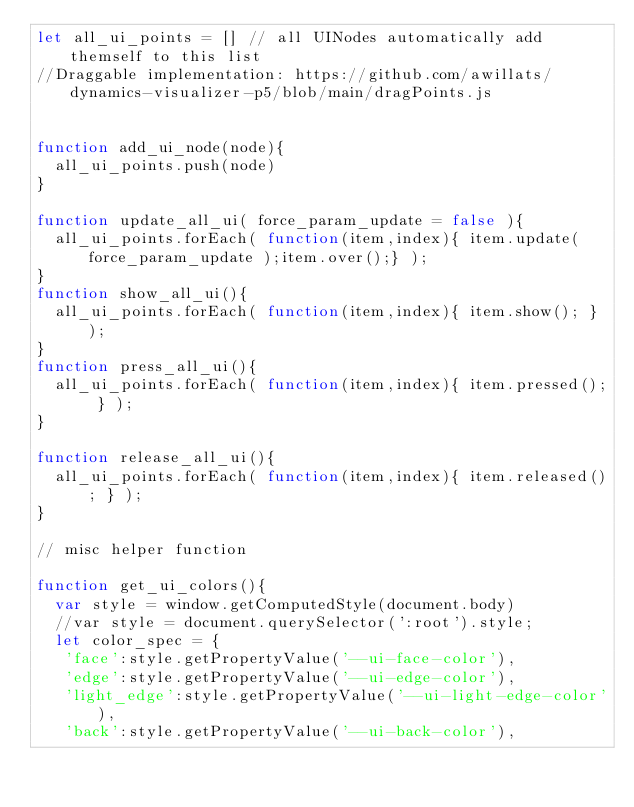<code> <loc_0><loc_0><loc_500><loc_500><_JavaScript_>let all_ui_points = [] // all UINodes automatically add themself to this list
//Draggable implementation: https://github.com/awillats/dynamics-visualizer-p5/blob/main/dragPoints.js


function add_ui_node(node){
  all_ui_points.push(node)
}

function update_all_ui( force_param_update = false ){
  all_ui_points.forEach( function(item,index){ item.update( force_param_update );item.over();} ); 
}
function show_all_ui(){
  all_ui_points.forEach( function(item,index){ item.show(); } ); 
}
function press_all_ui(){
  all_ui_points.forEach( function(item,index){ item.pressed(); } ); 
}

function release_all_ui(){
  all_ui_points.forEach( function(item,index){ item.released(); } ); 
}

// misc helper function 

function get_ui_colors(){
  var style = window.getComputedStyle(document.body)
  //var style = document.querySelector(':root').style;
  let color_spec = {
   'face':style.getPropertyValue('--ui-face-color'),
   'edge':style.getPropertyValue('--ui-edge-color'),
   'light_edge':style.getPropertyValue('--ui-light-edge-color'),
   'back':style.getPropertyValue('--ui-back-color'),</code> 